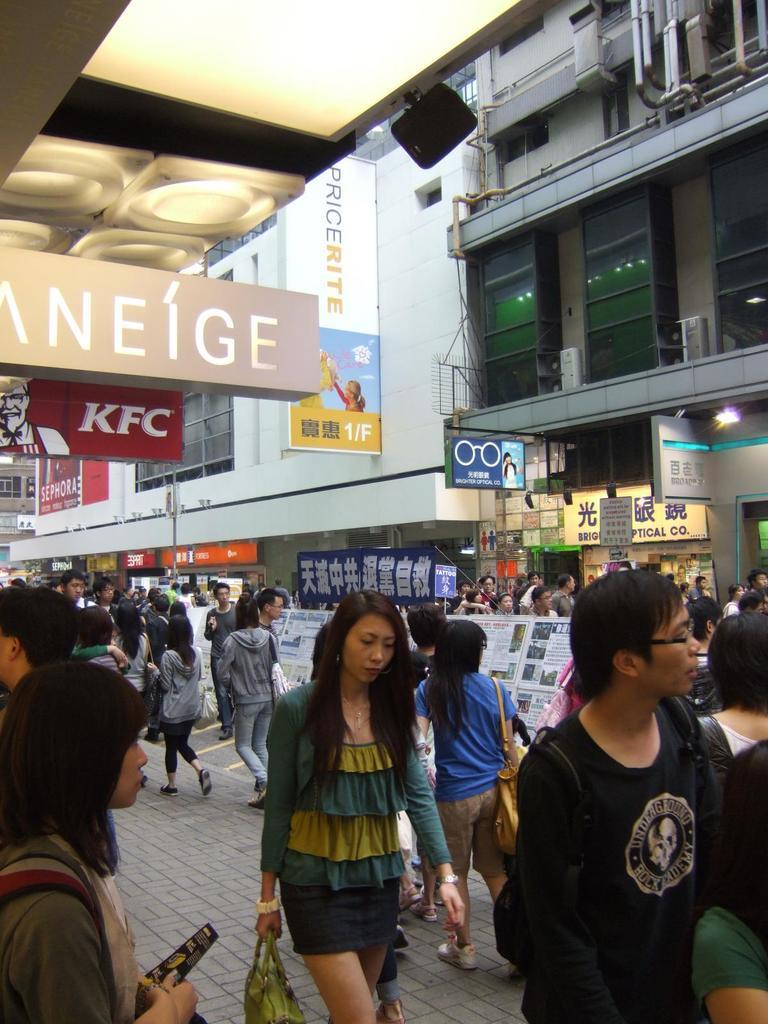Please provide a concise description of this image. In this image there are people walking on a path, in the background there are buildings, for that buildings there are banners on that banner there are text. 